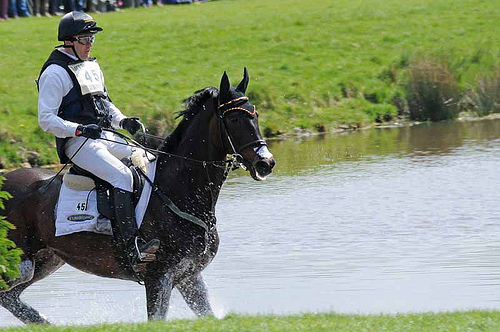Do the gloves have a different color than the pants? Yes, the gloves are a different color than the pants. 